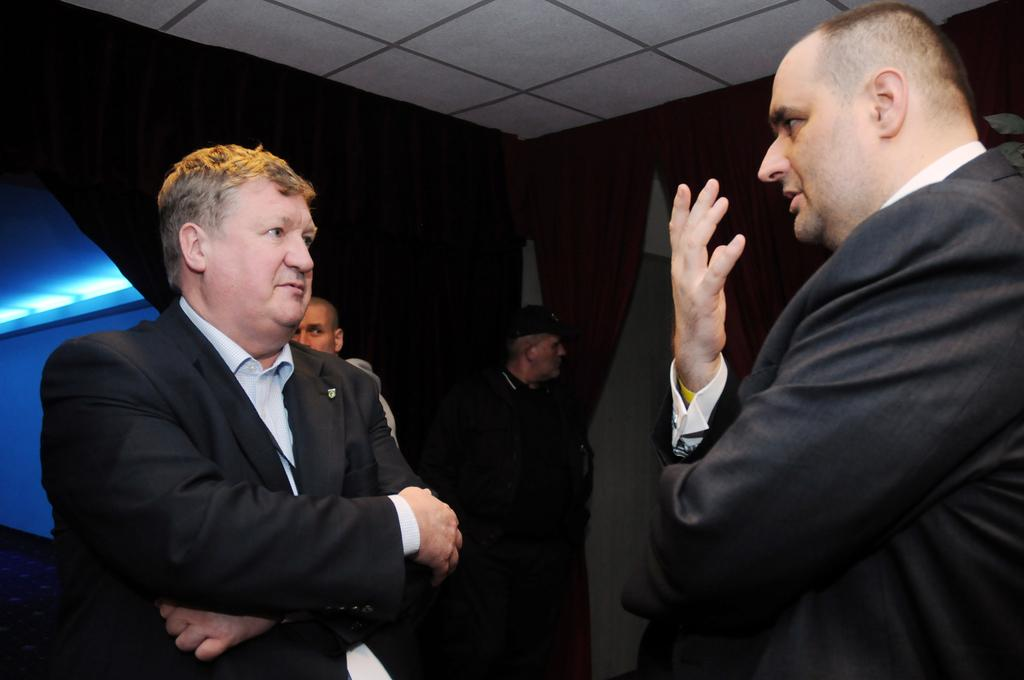How many people are in the group visible in the image? There is a group of people standing in the image, but the exact number cannot be determined without more specific information. What type of structure is visible in the image? There is a wall and a roof visible in the image, suggesting that the group of people might be standing in a building or an enclosed area. What type of rice is being cooked by the brothers in the image? There is no reference to any brothers or rice in the image, so it is not possible to answer that question. 